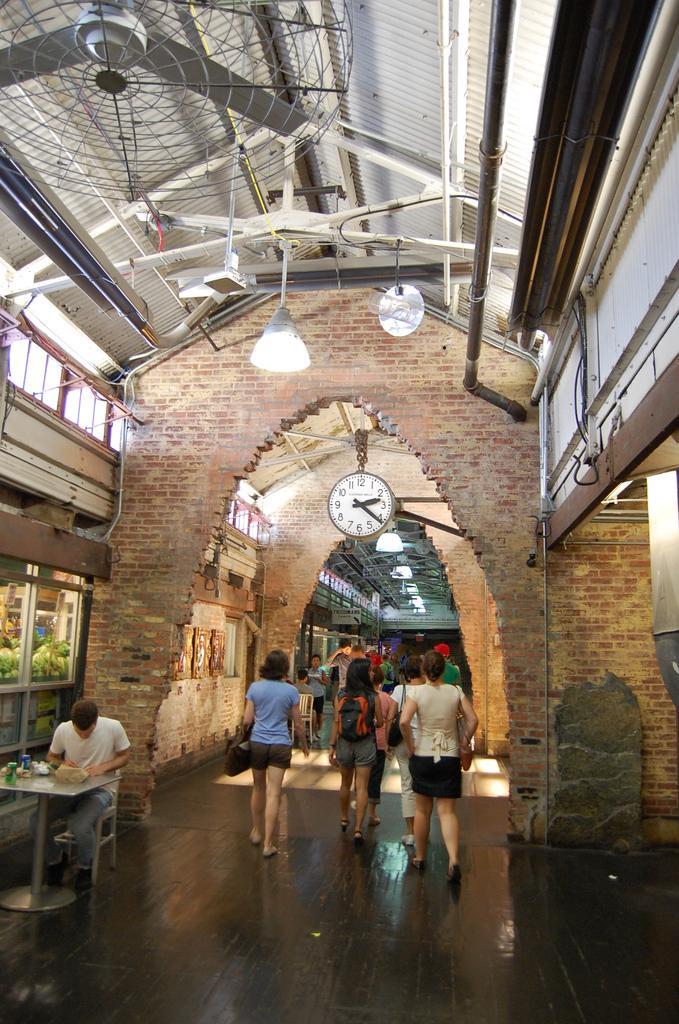Describe this image in one or two sentences. This is inside view picture. At the top we can see a shed, roof. This is alight. This is a fan. this is a wall with bricks. Here we can see a group of people walking on the floor. At the left side of the picture we can see one man sitting. On the table there are few items. We can also see window here. These are the lights. This is a clock. 